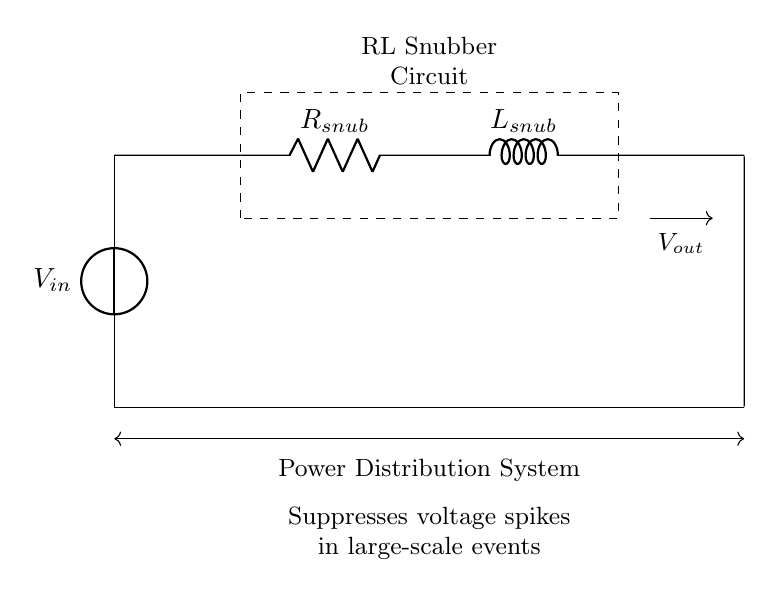What is the input voltage of the circuit? The input voltage is labeled as V_in in the circuit diagram, which connects to the top of the RL snubber circuit.
Answer: V_in What type of components are used in this circuit? The circuit includes a resistor (R_snub) and an inductor (L_snub), which are the key components for creating an RL snubber circuit.
Answer: Resistor and Inductor What does the dashed rectangle represent in the circuit? The dashed rectangle encompasses the RL snubber circuit, indicating it as a distinct functional unit within the overall power distribution system.
Answer: RL Snubber Circuit How does the RL snubber circuit affect voltage spikes? The RL snubber circuit suppresses voltage spikes by utilizing the characteristics of the resistor and inductor to dampen transient voltages that occur in the power system.
Answer: Suppresses voltage spikes What is the output voltage direction in the circuit? The output voltage is denoted by the arrow pointing from the inductor to the lower part of the circuit, indicating the flow from the RL snubber circuit into the distribution system.
Answer: From inductor to ground Why is a resistor used in the RL snubber circuit? The resistor is used to dissipate energy and limit the current flow, which helps stabilize and control the voltage across the inductor during transient events.
Answer: Energy dissipation and current limitation 